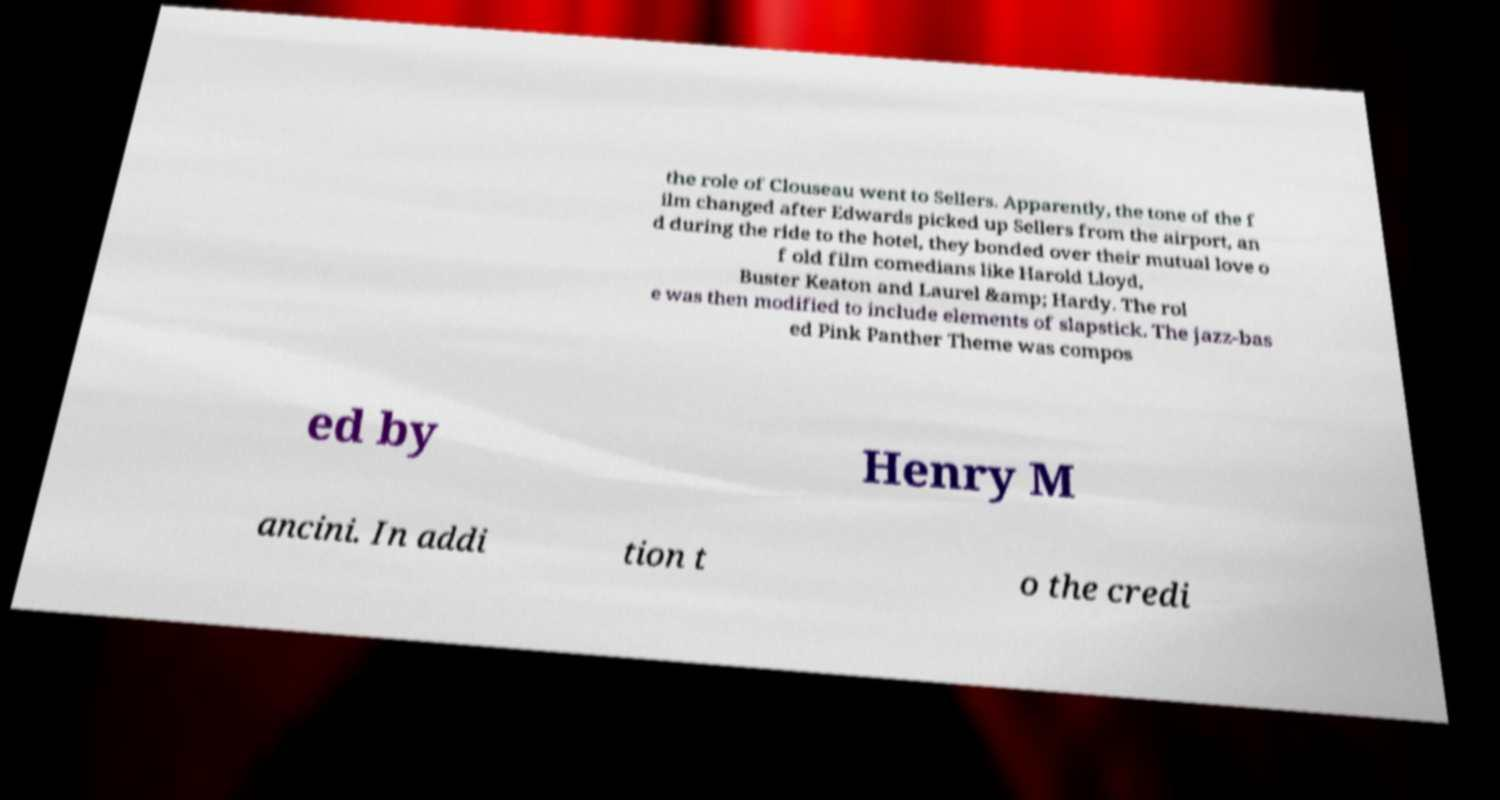Can you read and provide the text displayed in the image?This photo seems to have some interesting text. Can you extract and type it out for me? the role of Clouseau went to Sellers. Apparently, the tone of the f ilm changed after Edwards picked up Sellers from the airport, an d during the ride to the hotel, they bonded over their mutual love o f old film comedians like Harold Lloyd, Buster Keaton and Laurel &amp; Hardy. The rol e was then modified to include elements of slapstick. The jazz-bas ed Pink Panther Theme was compos ed by Henry M ancini. In addi tion t o the credi 